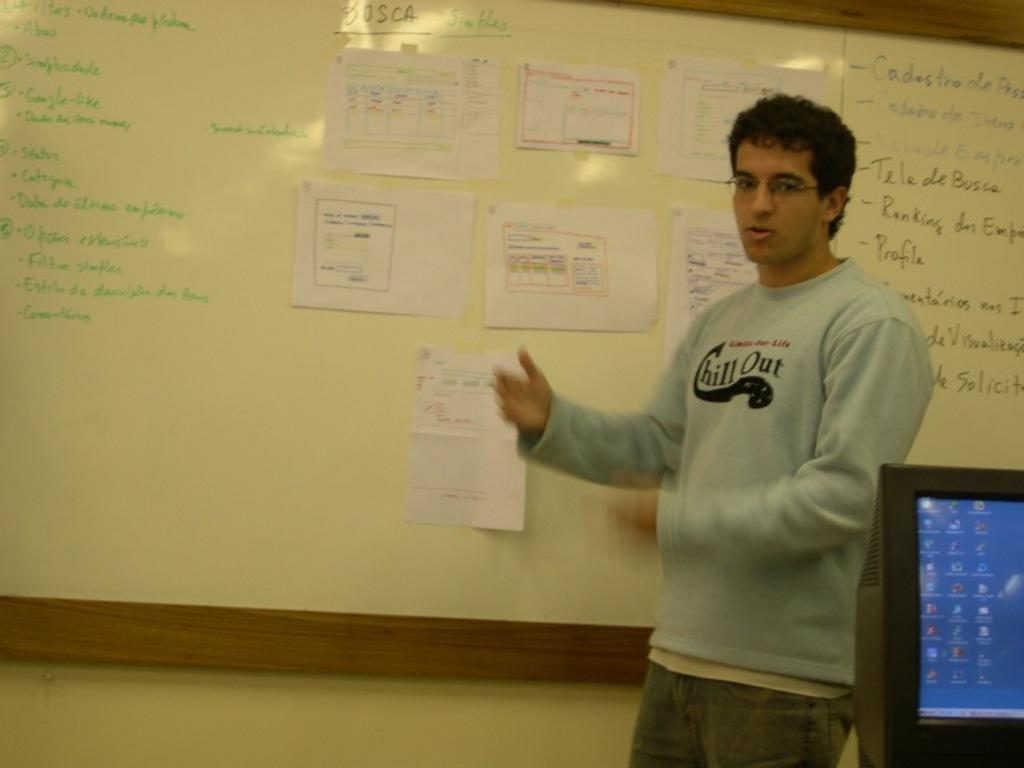What does the man's shirt recommend you do?
Offer a terse response. Chill out. What does the word in the middle of the board at the top say?
Offer a terse response. Bosca. 